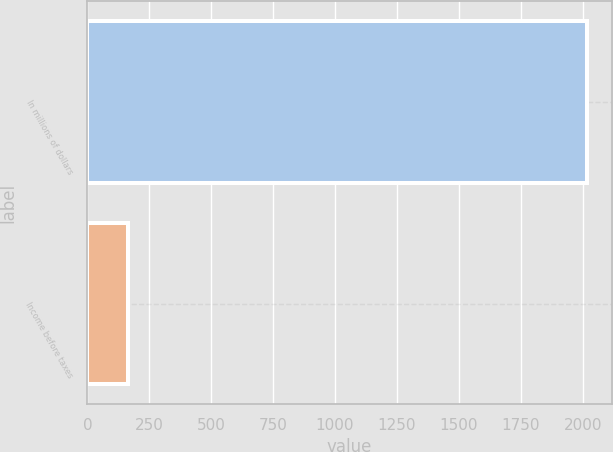Convert chart to OTSL. <chart><loc_0><loc_0><loc_500><loc_500><bar_chart><fcel>In millions of dollars<fcel>Income before taxes<nl><fcel>2017<fcel>164<nl></chart> 